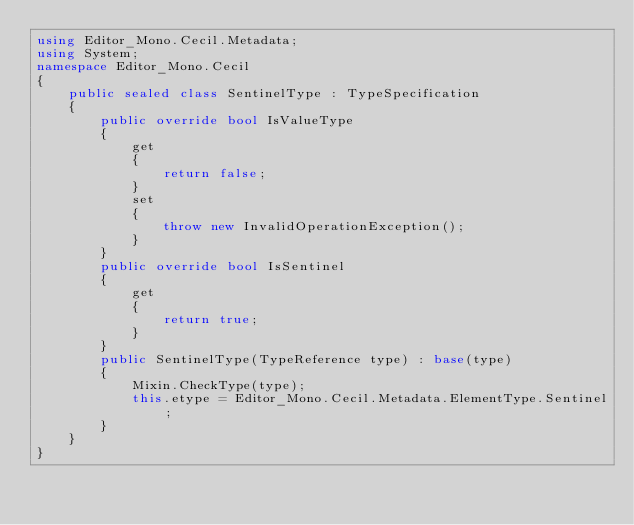Convert code to text. <code><loc_0><loc_0><loc_500><loc_500><_C#_>using Editor_Mono.Cecil.Metadata;
using System;
namespace Editor_Mono.Cecil
{
	public sealed class SentinelType : TypeSpecification
	{
		public override bool IsValueType
		{
			get
			{
				return false;
			}
			set
			{
				throw new InvalidOperationException();
			}
		}
		public override bool IsSentinel
		{
			get
			{
				return true;
			}
		}
		public SentinelType(TypeReference type) : base(type)
		{
			Mixin.CheckType(type);
			this.etype = Editor_Mono.Cecil.Metadata.ElementType.Sentinel;
		}
	}
}
</code> 